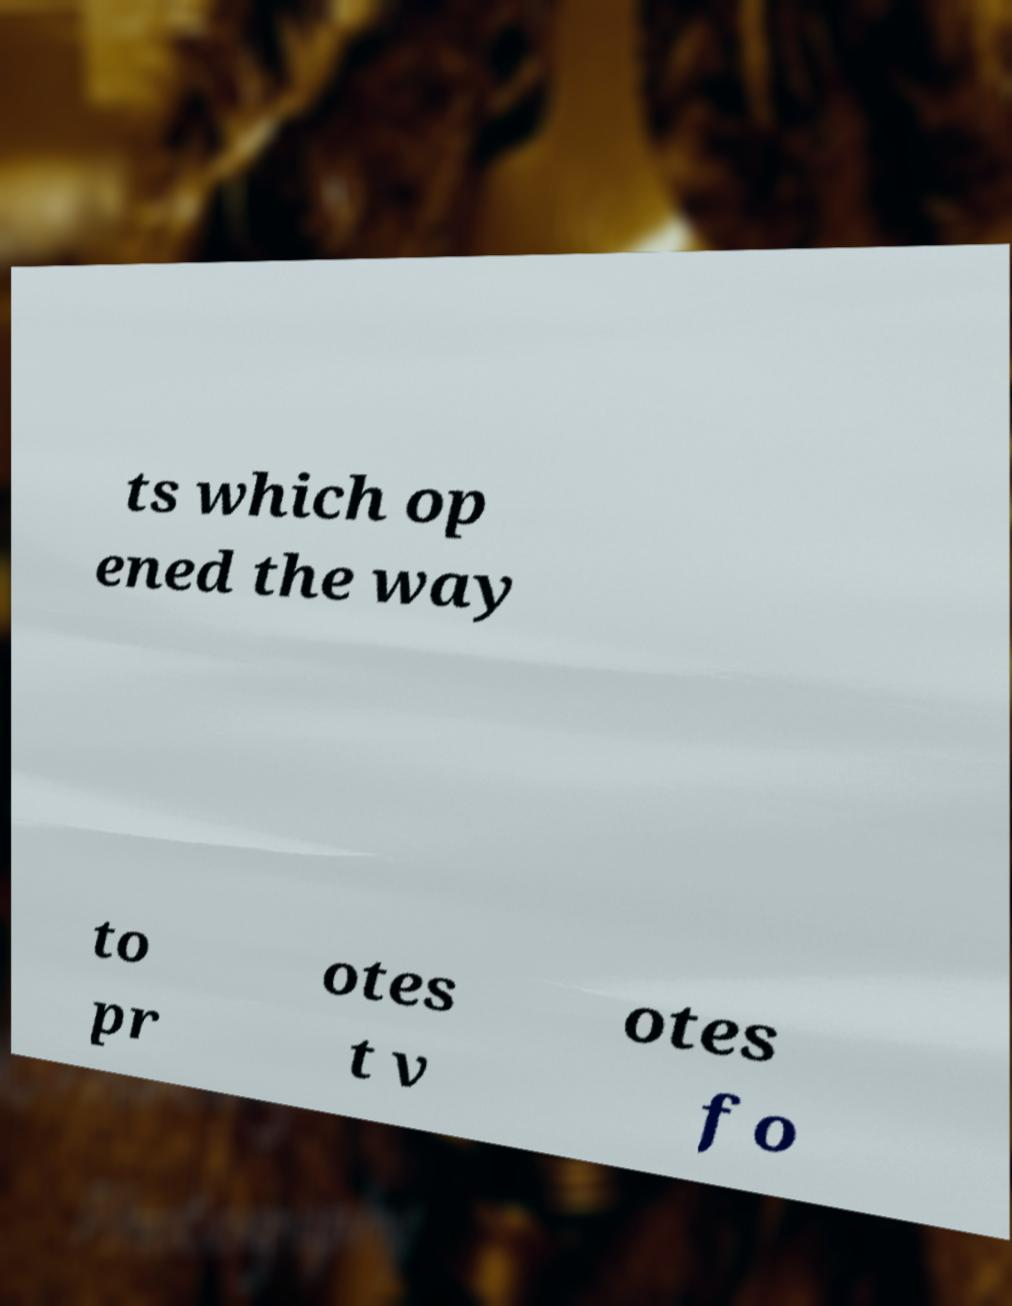Please read and relay the text visible in this image. What does it say? ts which op ened the way to pr otes t v otes fo 